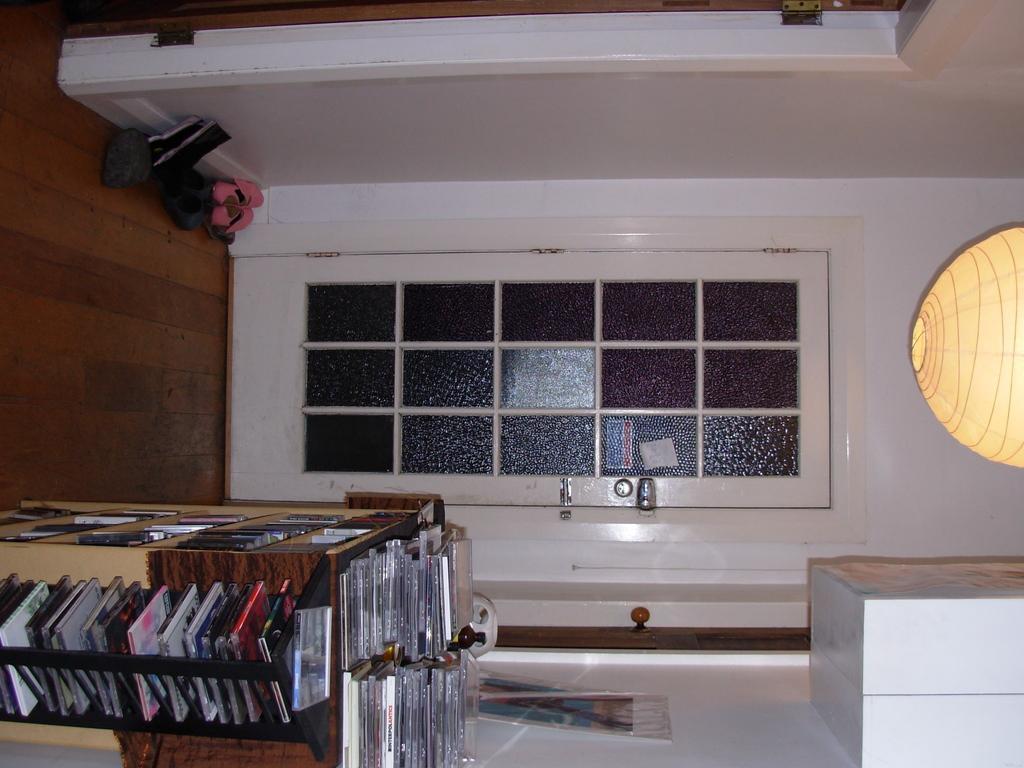Can you describe this image briefly? In this image we can see discs arranged in the cupboards, door and walls. 